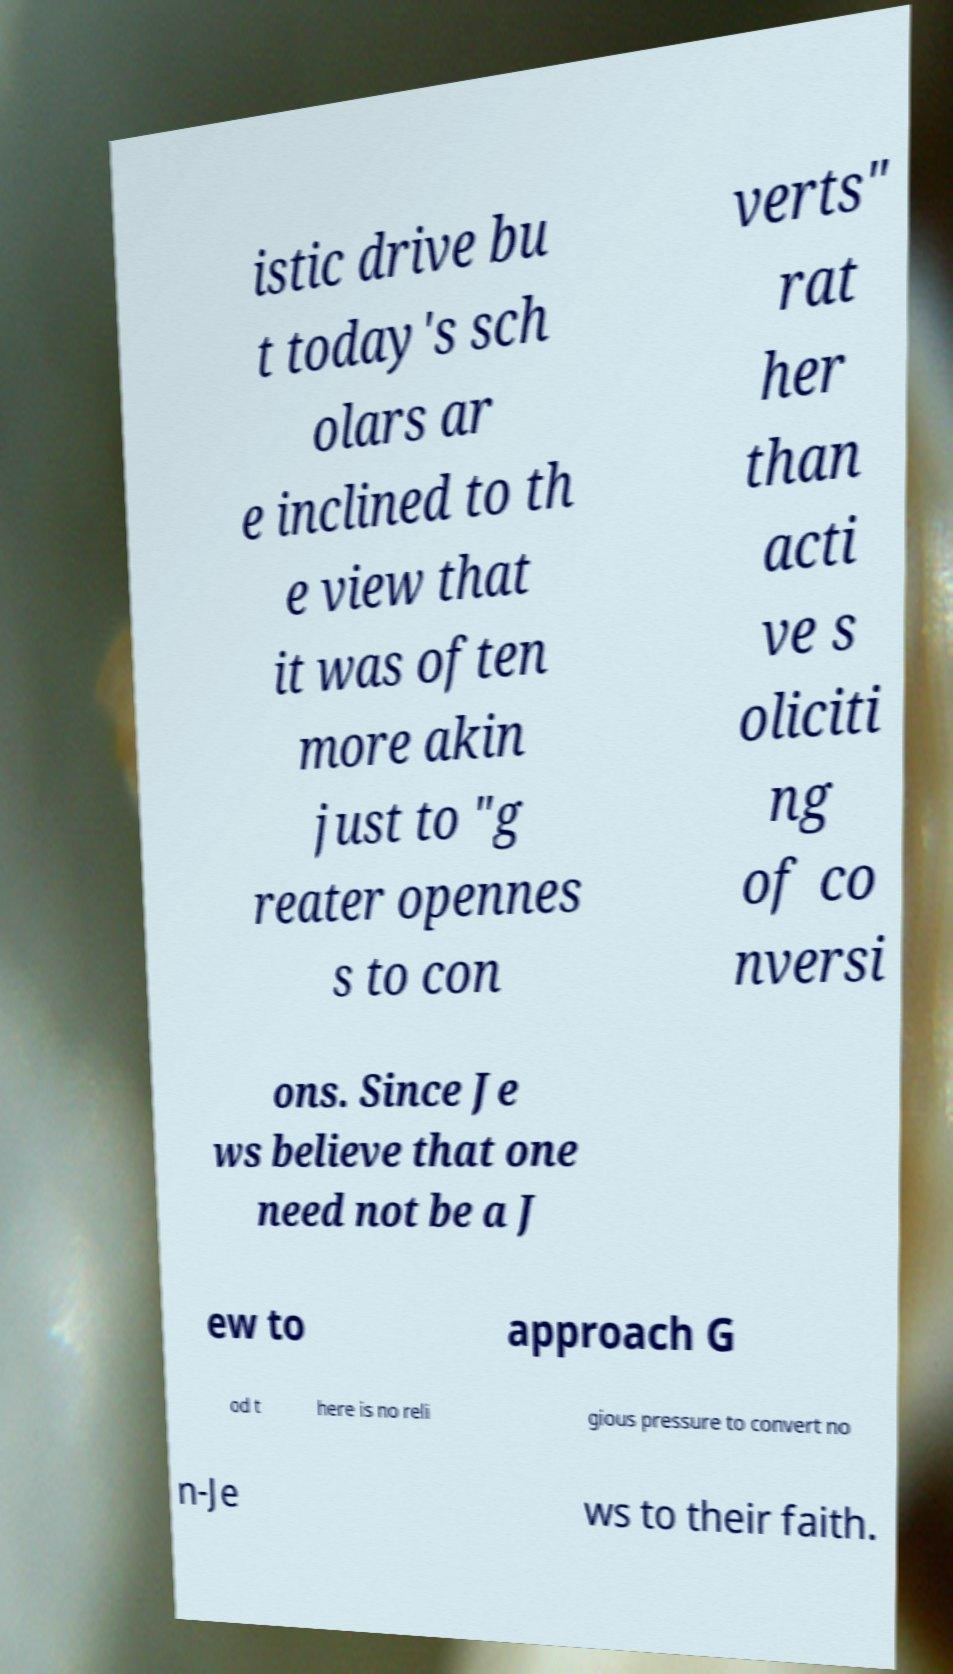There's text embedded in this image that I need extracted. Can you transcribe it verbatim? istic drive bu t today's sch olars ar e inclined to th e view that it was often more akin just to "g reater opennes s to con verts" rat her than acti ve s oliciti ng of co nversi ons. Since Je ws believe that one need not be a J ew to approach G od t here is no reli gious pressure to convert no n-Je ws to their faith. 